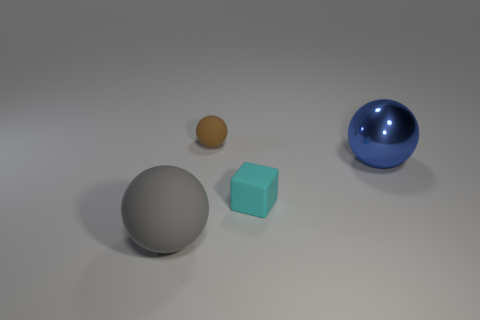Add 3 metallic objects. How many objects exist? 7 Subtract all small spheres. How many spheres are left? 2 Subtract all brown balls. How many balls are left? 2 Subtract all blocks. How many objects are left? 3 Add 2 small brown matte spheres. How many small brown matte spheres are left? 3 Add 4 tiny brown rubber objects. How many tiny brown rubber objects exist? 5 Subtract 0 purple balls. How many objects are left? 4 Subtract all purple cubes. Subtract all gray cylinders. How many cubes are left? 1 Subtract all red balls. How many green cubes are left? 0 Subtract all tiny purple matte blocks. Subtract all brown spheres. How many objects are left? 3 